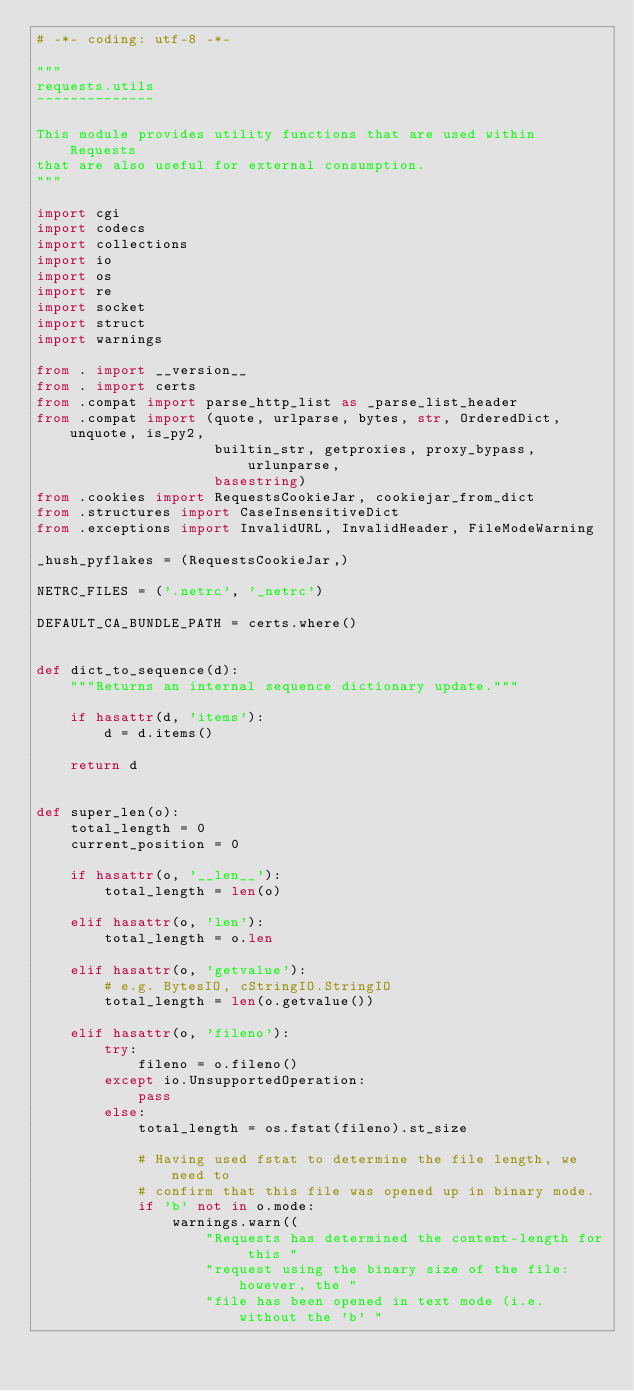<code> <loc_0><loc_0><loc_500><loc_500><_Python_># -*- coding: utf-8 -*-

"""
requests.utils
~~~~~~~~~~~~~~

This module provides utility functions that are used within Requests
that are also useful for external consumption.
"""

import cgi
import codecs
import collections
import io
import os
import re
import socket
import struct
import warnings

from . import __version__
from . import certs
from .compat import parse_http_list as _parse_list_header
from .compat import (quote, urlparse, bytes, str, OrderedDict, unquote, is_py2,
                     builtin_str, getproxies, proxy_bypass, urlunparse,
                     basestring)
from .cookies import RequestsCookieJar, cookiejar_from_dict
from .structures import CaseInsensitiveDict
from .exceptions import InvalidURL, InvalidHeader, FileModeWarning

_hush_pyflakes = (RequestsCookieJar,)

NETRC_FILES = ('.netrc', '_netrc')

DEFAULT_CA_BUNDLE_PATH = certs.where()


def dict_to_sequence(d):
    """Returns an internal sequence dictionary update."""

    if hasattr(d, 'items'):
        d = d.items()

    return d


def super_len(o):
    total_length = 0
    current_position = 0

    if hasattr(o, '__len__'):
        total_length = len(o)

    elif hasattr(o, 'len'):
        total_length = o.len

    elif hasattr(o, 'getvalue'):
        # e.g. BytesIO, cStringIO.StringIO
        total_length = len(o.getvalue())

    elif hasattr(o, 'fileno'):
        try:
            fileno = o.fileno()
        except io.UnsupportedOperation:
            pass
        else:
            total_length = os.fstat(fileno).st_size

            # Having used fstat to determine the file length, we need to
            # confirm that this file was opened up in binary mode.
            if 'b' not in o.mode:
                warnings.warn((
                    "Requests has determined the content-length for this "
                    "request using the binary size of the file: however, the "
                    "file has been opened in text mode (i.e. without the 'b' "</code> 